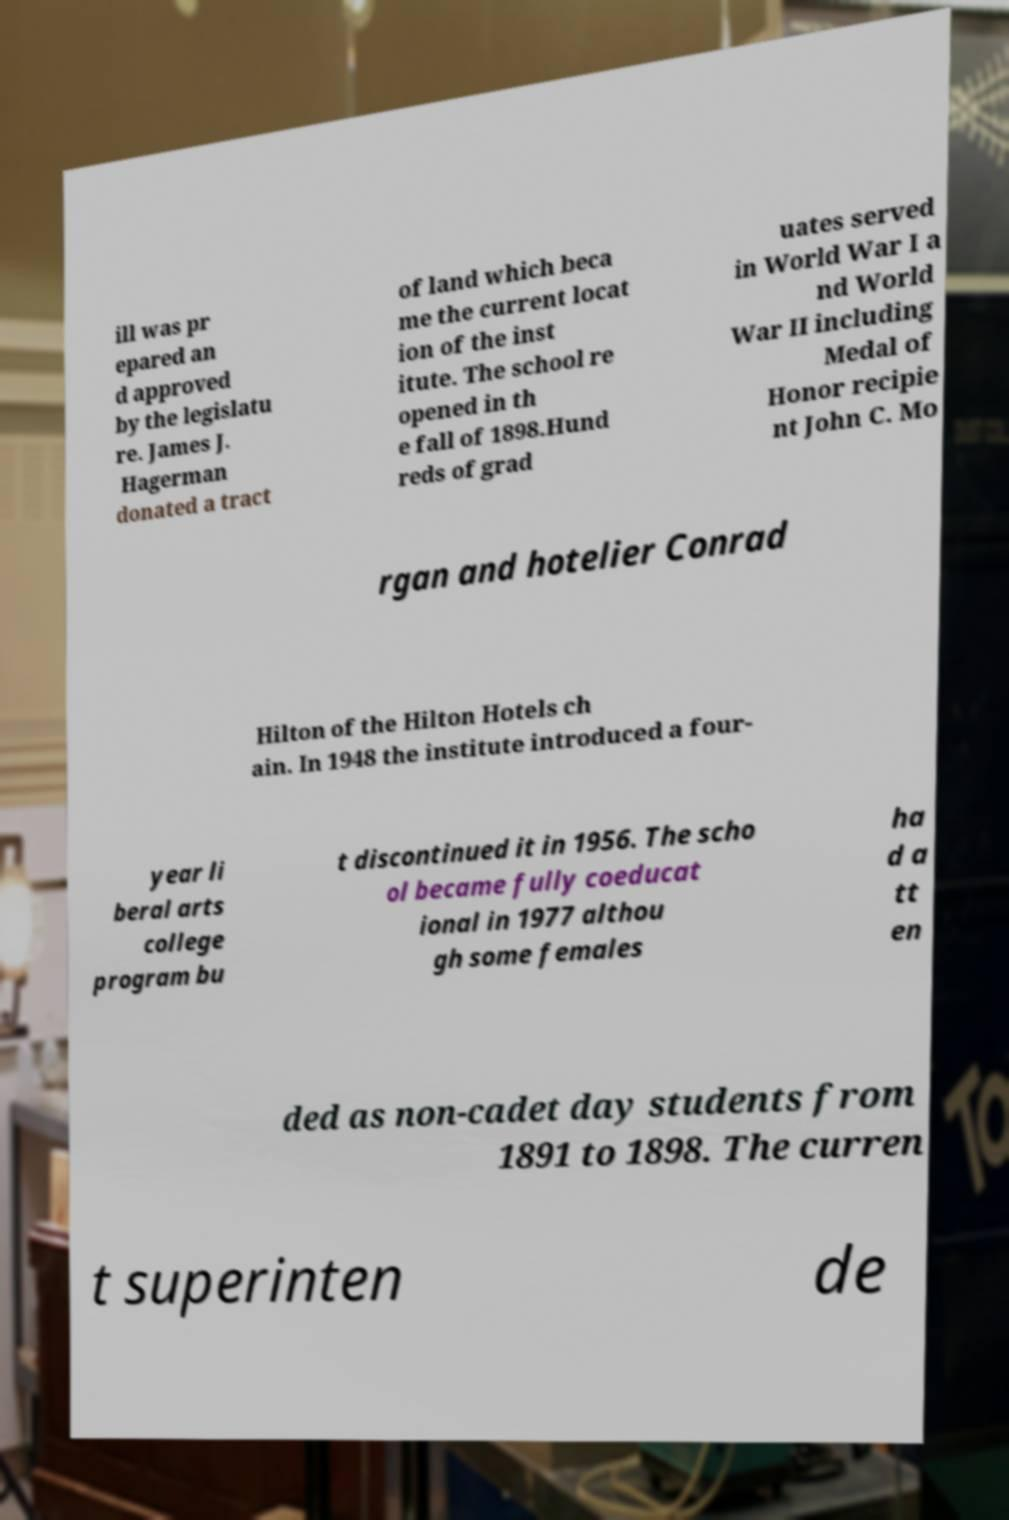Could you extract and type out the text from this image? ill was pr epared an d approved by the legislatu re. James J. Hagerman donated a tract of land which beca me the current locat ion of the inst itute. The school re opened in th e fall of 1898.Hund reds of grad uates served in World War I a nd World War II including Medal of Honor recipie nt John C. Mo rgan and hotelier Conrad Hilton of the Hilton Hotels ch ain. In 1948 the institute introduced a four- year li beral arts college program bu t discontinued it in 1956. The scho ol became fully coeducat ional in 1977 althou gh some females ha d a tt en ded as non-cadet day students from 1891 to 1898. The curren t superinten de 